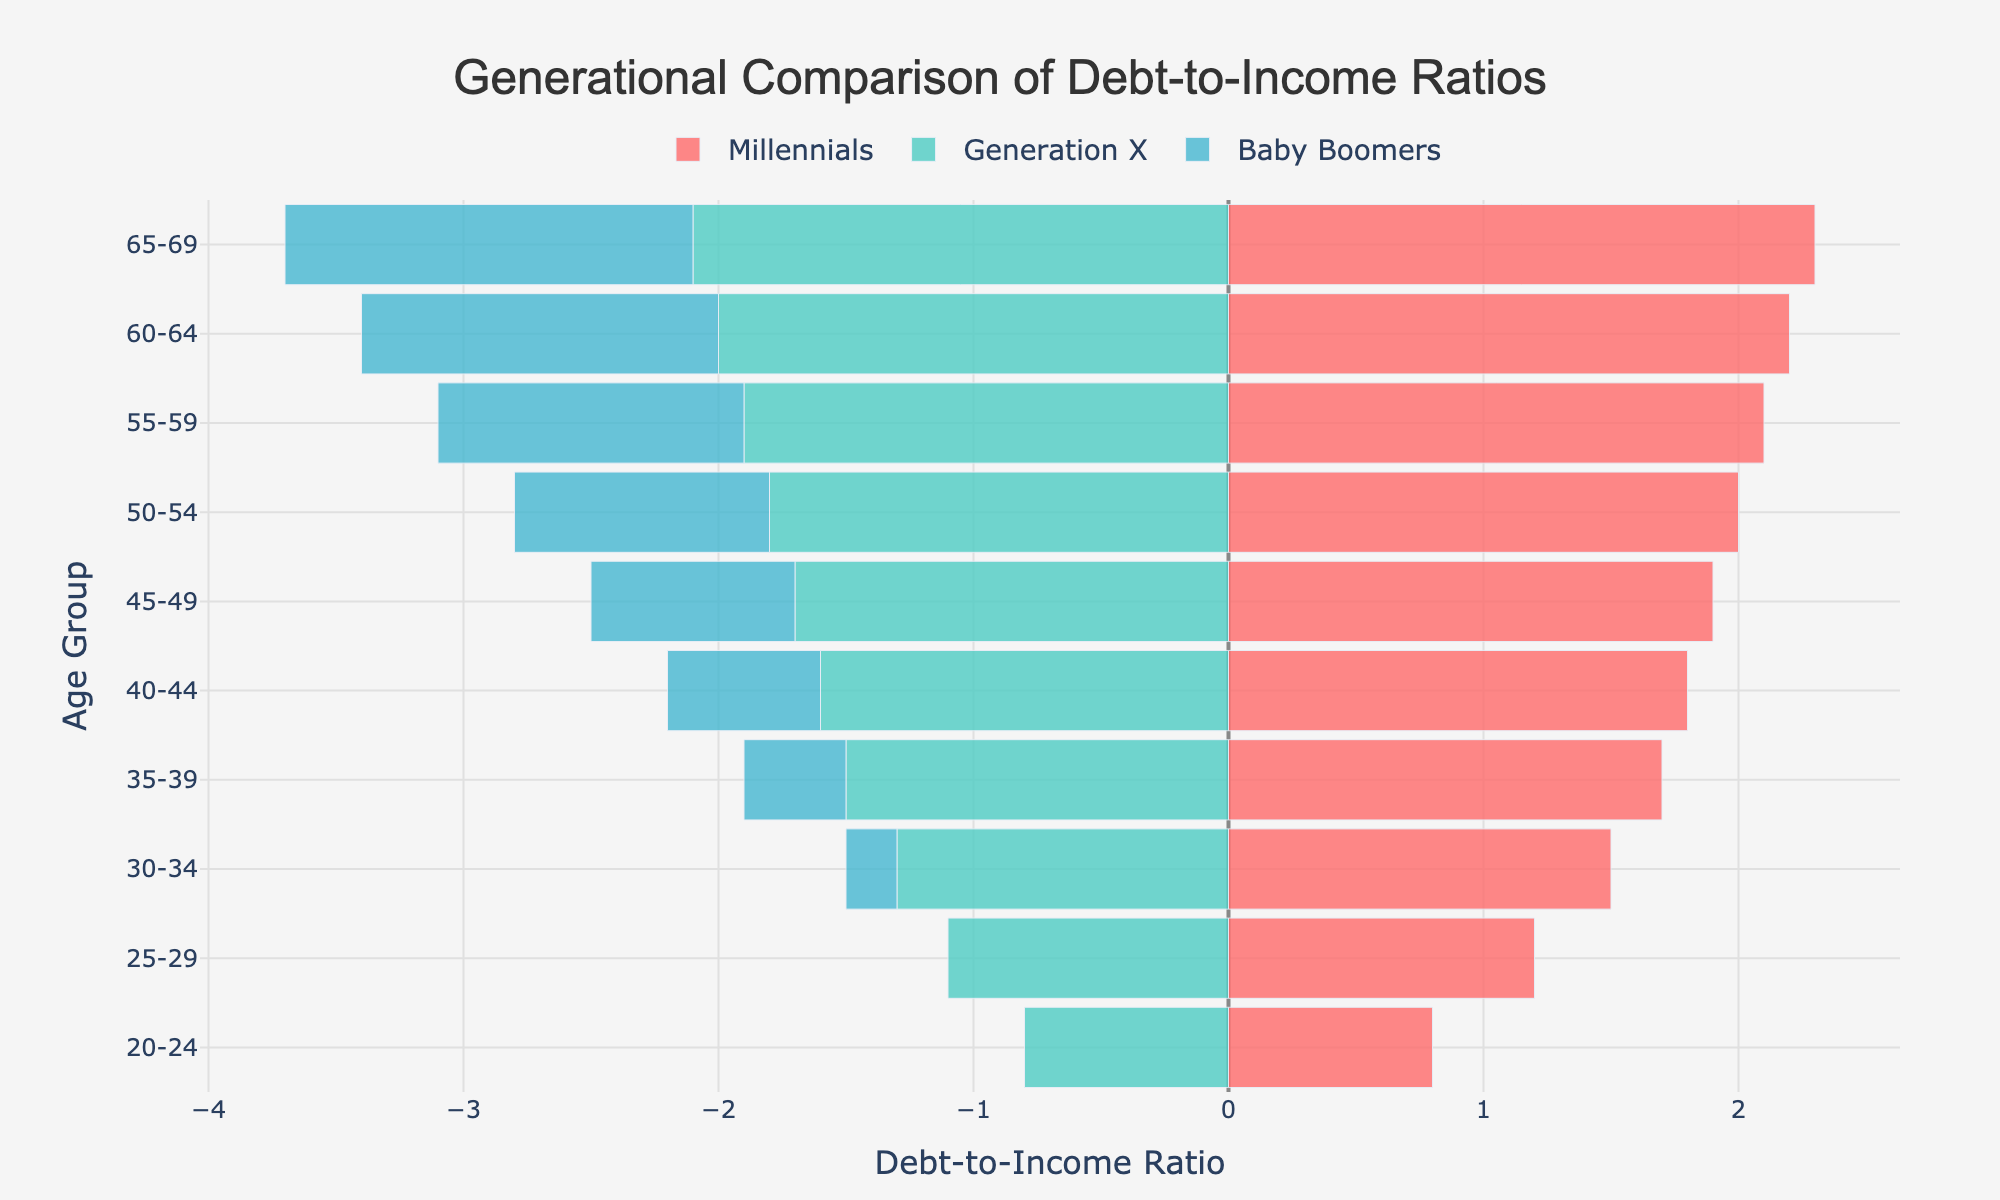What's the title of the figure? The title of the figure is displayed prominently at the top.
Answer: Generational Comparison of Debt-to-Income Ratios What colors represent each generation? The figure uses distinct colors for each generation, with Millennials in red, Generation X in green, and Baby Boomers in blue.
Answer: Red (Millennials), Green (Generation X), Blue (Baby Boomers) Which age group has the highest debt-to-income ratio for Millennials? By looking at the length of the bars for Millennials, the longest bar corresponds to the age group 65-69.
Answer: 65-69 How does the debt-to-income ratio for Generation X change as the age group increases? By observing the ratios throughout the age groups for Generation X, we can see they become more negative with age, indicating an increase in financial stability.
Answer: Decreases (becomes more negative) How does the debt-to-income ratio for Millennials between 40-44 compare to that of Baby Boomers? Comparing the bar lengths, Millennials (1.8) have a higher debt-to-income ratio than Baby Boomers (-0.6) for the age group 40-44.
Answer: Millennials have a higher ratio What is the difference in debt-to-income ratios between Millennials and Generation X for the age group 30-34? The debt-to-income ratio for Millennials is 1.5 and for Generation X is -1.3 in the age group 30-34. The difference is 1.5 - (-1.3) = 2.8.
Answer: 2.8 Which generation has the least negative debt-to-income ratio in the age group 55-59? Looking at the bar lengths for age group 55-59, Baby Boomers have a ratio of -1.2, which is the least negative compared to Generation X.
Answer: Baby Boomers Across all age groups, which generation shows a consistently increasing trend in their debt-to-income ratio? Observing the bar lengths for each generation, Millennials show a consistently increasing trend in debt-to-income ratio as age increases.
Answer: Millennials What is the average debt-to-income ratio for Millennials between the ages of 40-49? The debt-to-income ratios for Millennials aged 40-49 are 1.8 and 1.9. The average is (1.8 + 1.9) / 2 = 1.85.
Answer: 1.85 Between Millennials and Baby Boomers, which generation's debt-to-income ratio fluctuates less across the age groups? Observing the range and consistency of the bars, Baby Boomers have a smoother and less fluctuating negative ratio compared to Millennials.
Answer: Baby Boomers 